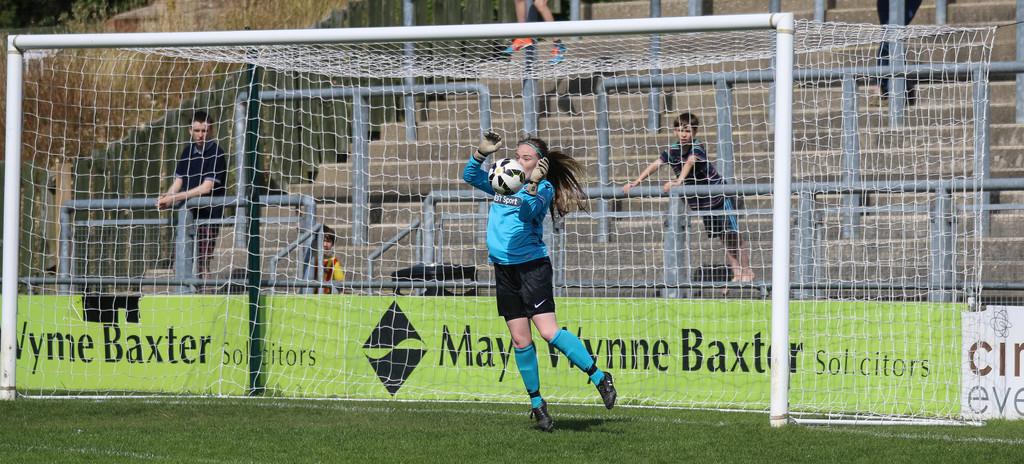Which company is being shown on the banner?
Provide a short and direct response. May wynne baxter. 